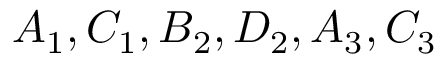<formula> <loc_0><loc_0><loc_500><loc_500>A _ { 1 } , C _ { 1 } , B _ { 2 } , D _ { 2 } , A _ { 3 } , C _ { 3 }</formula> 